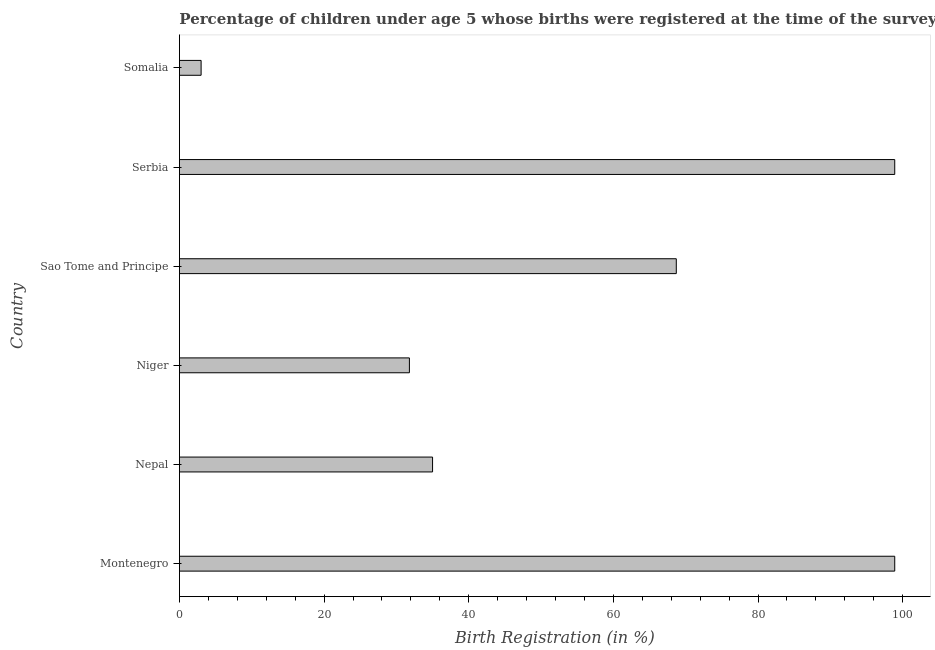Does the graph contain any zero values?
Your answer should be compact. No. Does the graph contain grids?
Keep it short and to the point. No. What is the title of the graph?
Offer a very short reply. Percentage of children under age 5 whose births were registered at the time of the survey in 2006. What is the label or title of the X-axis?
Offer a very short reply. Birth Registration (in %). What is the birth registration in Sao Tome and Principe?
Offer a terse response. 68.7. Across all countries, what is the maximum birth registration?
Your response must be concise. 98.9. Across all countries, what is the minimum birth registration?
Provide a succinct answer. 3. In which country was the birth registration maximum?
Offer a very short reply. Montenegro. In which country was the birth registration minimum?
Give a very brief answer. Somalia. What is the sum of the birth registration?
Offer a terse response. 336.3. What is the difference between the birth registration in Montenegro and Niger?
Offer a very short reply. 67.1. What is the average birth registration per country?
Provide a succinct answer. 56.05. What is the median birth registration?
Your answer should be compact. 51.85. What is the ratio of the birth registration in Sao Tome and Principe to that in Serbia?
Ensure brevity in your answer.  0.69. Is the birth registration in Montenegro less than that in Niger?
Provide a succinct answer. No. Is the sum of the birth registration in Niger and Sao Tome and Principe greater than the maximum birth registration across all countries?
Offer a very short reply. Yes. What is the difference between the highest and the lowest birth registration?
Make the answer very short. 95.9. How many bars are there?
Your answer should be very brief. 6. What is the difference between two consecutive major ticks on the X-axis?
Ensure brevity in your answer.  20. What is the Birth Registration (in %) in Montenegro?
Ensure brevity in your answer.  98.9. What is the Birth Registration (in %) of Nepal?
Your answer should be very brief. 35. What is the Birth Registration (in %) in Niger?
Keep it short and to the point. 31.8. What is the Birth Registration (in %) of Sao Tome and Principe?
Your answer should be very brief. 68.7. What is the Birth Registration (in %) in Serbia?
Give a very brief answer. 98.9. What is the difference between the Birth Registration (in %) in Montenegro and Nepal?
Provide a succinct answer. 63.9. What is the difference between the Birth Registration (in %) in Montenegro and Niger?
Give a very brief answer. 67.1. What is the difference between the Birth Registration (in %) in Montenegro and Sao Tome and Principe?
Your answer should be very brief. 30.2. What is the difference between the Birth Registration (in %) in Montenegro and Serbia?
Provide a succinct answer. 0. What is the difference between the Birth Registration (in %) in Montenegro and Somalia?
Offer a very short reply. 95.9. What is the difference between the Birth Registration (in %) in Nepal and Sao Tome and Principe?
Your answer should be very brief. -33.7. What is the difference between the Birth Registration (in %) in Nepal and Serbia?
Give a very brief answer. -63.9. What is the difference between the Birth Registration (in %) in Nepal and Somalia?
Your response must be concise. 32. What is the difference between the Birth Registration (in %) in Niger and Sao Tome and Principe?
Ensure brevity in your answer.  -36.9. What is the difference between the Birth Registration (in %) in Niger and Serbia?
Give a very brief answer. -67.1. What is the difference between the Birth Registration (in %) in Niger and Somalia?
Offer a very short reply. 28.8. What is the difference between the Birth Registration (in %) in Sao Tome and Principe and Serbia?
Your answer should be very brief. -30.2. What is the difference between the Birth Registration (in %) in Sao Tome and Principe and Somalia?
Make the answer very short. 65.7. What is the difference between the Birth Registration (in %) in Serbia and Somalia?
Provide a succinct answer. 95.9. What is the ratio of the Birth Registration (in %) in Montenegro to that in Nepal?
Make the answer very short. 2.83. What is the ratio of the Birth Registration (in %) in Montenegro to that in Niger?
Your answer should be very brief. 3.11. What is the ratio of the Birth Registration (in %) in Montenegro to that in Sao Tome and Principe?
Your response must be concise. 1.44. What is the ratio of the Birth Registration (in %) in Montenegro to that in Serbia?
Make the answer very short. 1. What is the ratio of the Birth Registration (in %) in Montenegro to that in Somalia?
Keep it short and to the point. 32.97. What is the ratio of the Birth Registration (in %) in Nepal to that in Niger?
Keep it short and to the point. 1.1. What is the ratio of the Birth Registration (in %) in Nepal to that in Sao Tome and Principe?
Offer a very short reply. 0.51. What is the ratio of the Birth Registration (in %) in Nepal to that in Serbia?
Provide a succinct answer. 0.35. What is the ratio of the Birth Registration (in %) in Nepal to that in Somalia?
Give a very brief answer. 11.67. What is the ratio of the Birth Registration (in %) in Niger to that in Sao Tome and Principe?
Your answer should be compact. 0.46. What is the ratio of the Birth Registration (in %) in Niger to that in Serbia?
Your response must be concise. 0.32. What is the ratio of the Birth Registration (in %) in Sao Tome and Principe to that in Serbia?
Provide a succinct answer. 0.69. What is the ratio of the Birth Registration (in %) in Sao Tome and Principe to that in Somalia?
Your answer should be very brief. 22.9. What is the ratio of the Birth Registration (in %) in Serbia to that in Somalia?
Offer a terse response. 32.97. 